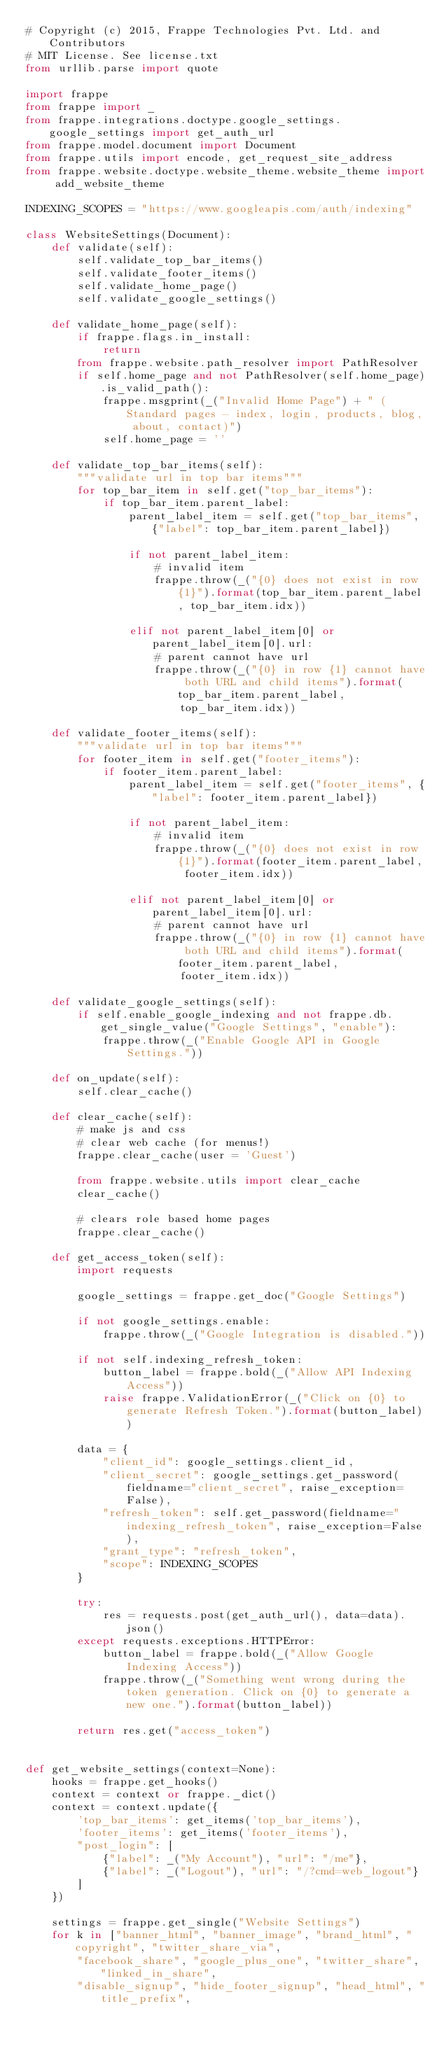Convert code to text. <code><loc_0><loc_0><loc_500><loc_500><_Python_># Copyright (c) 2015, Frappe Technologies Pvt. Ltd. and Contributors
# MIT License. See license.txt
from urllib.parse import quote

import frappe
from frappe import _
from frappe.integrations.doctype.google_settings.google_settings import get_auth_url
from frappe.model.document import Document
from frappe.utils import encode, get_request_site_address
from frappe.website.doctype.website_theme.website_theme import add_website_theme

INDEXING_SCOPES = "https://www.googleapis.com/auth/indexing"

class WebsiteSettings(Document):
	def validate(self):
		self.validate_top_bar_items()
		self.validate_footer_items()
		self.validate_home_page()
		self.validate_google_settings()

	def validate_home_page(self):
		if frappe.flags.in_install:
			return
		from frappe.website.path_resolver import PathResolver
		if self.home_page and not PathResolver(self.home_page).is_valid_path():
			frappe.msgprint(_("Invalid Home Page") + " (Standard pages - index, login, products, blog, about, contact)")
			self.home_page = ''

	def validate_top_bar_items(self):
		"""validate url in top bar items"""
		for top_bar_item in self.get("top_bar_items"):
			if top_bar_item.parent_label:
				parent_label_item = self.get("top_bar_items", {"label": top_bar_item.parent_label})

				if not parent_label_item:
					# invalid item
					frappe.throw(_("{0} does not exist in row {1}").format(top_bar_item.parent_label, top_bar_item.idx))

				elif not parent_label_item[0] or parent_label_item[0].url:
					# parent cannot have url
					frappe.throw(_("{0} in row {1} cannot have both URL and child items").format(top_bar_item.parent_label,
						top_bar_item.idx))

	def validate_footer_items(self):
		"""validate url in top bar items"""
		for footer_item in self.get("footer_items"):
			if footer_item.parent_label:
				parent_label_item = self.get("footer_items", {"label": footer_item.parent_label})

				if not parent_label_item:
					# invalid item
					frappe.throw(_("{0} does not exist in row {1}").format(footer_item.parent_label, footer_item.idx))

				elif not parent_label_item[0] or parent_label_item[0].url:
					# parent cannot have url
					frappe.throw(_("{0} in row {1} cannot have both URL and child items").format(footer_item.parent_label,
						footer_item.idx))

	def validate_google_settings(self):
		if self.enable_google_indexing and not frappe.db.get_single_value("Google Settings", "enable"):
			frappe.throw(_("Enable Google API in Google Settings."))

	def on_update(self):
		self.clear_cache()

	def clear_cache(self):
		# make js and css
		# clear web cache (for menus!)
		frappe.clear_cache(user = 'Guest')

		from frappe.website.utils import clear_cache
		clear_cache()

		# clears role based home pages
		frappe.clear_cache()

	def get_access_token(self):
		import requests

		google_settings = frappe.get_doc("Google Settings")

		if not google_settings.enable:
			frappe.throw(_("Google Integration is disabled."))

		if not self.indexing_refresh_token:
			button_label = frappe.bold(_("Allow API Indexing Access"))
			raise frappe.ValidationError(_("Click on {0} to generate Refresh Token.").format(button_label))

		data = {
			"client_id": google_settings.client_id,
			"client_secret": google_settings.get_password(fieldname="client_secret", raise_exception=False),
			"refresh_token": self.get_password(fieldname="indexing_refresh_token", raise_exception=False),
			"grant_type": "refresh_token",
			"scope": INDEXING_SCOPES
		}

		try:
			res = requests.post(get_auth_url(), data=data).json()
		except requests.exceptions.HTTPError:
			button_label = frappe.bold(_("Allow Google Indexing Access"))
			frappe.throw(_("Something went wrong during the token generation. Click on {0} to generate a new one.").format(button_label))

		return res.get("access_token")


def get_website_settings(context=None):
	hooks = frappe.get_hooks()
	context = context or frappe._dict()
	context = context.update({
		'top_bar_items': get_items('top_bar_items'),
		'footer_items': get_items('footer_items'),
		"post_login": [
			{"label": _("My Account"), "url": "/me"},
			{"label": _("Logout"), "url": "/?cmd=web_logout"}
		]
	})

	settings = frappe.get_single("Website Settings")
	for k in ["banner_html", "banner_image", "brand_html", "copyright", "twitter_share_via",
		"facebook_share", "google_plus_one", "twitter_share", "linked_in_share",
		"disable_signup", "hide_footer_signup", "head_html", "title_prefix",</code> 